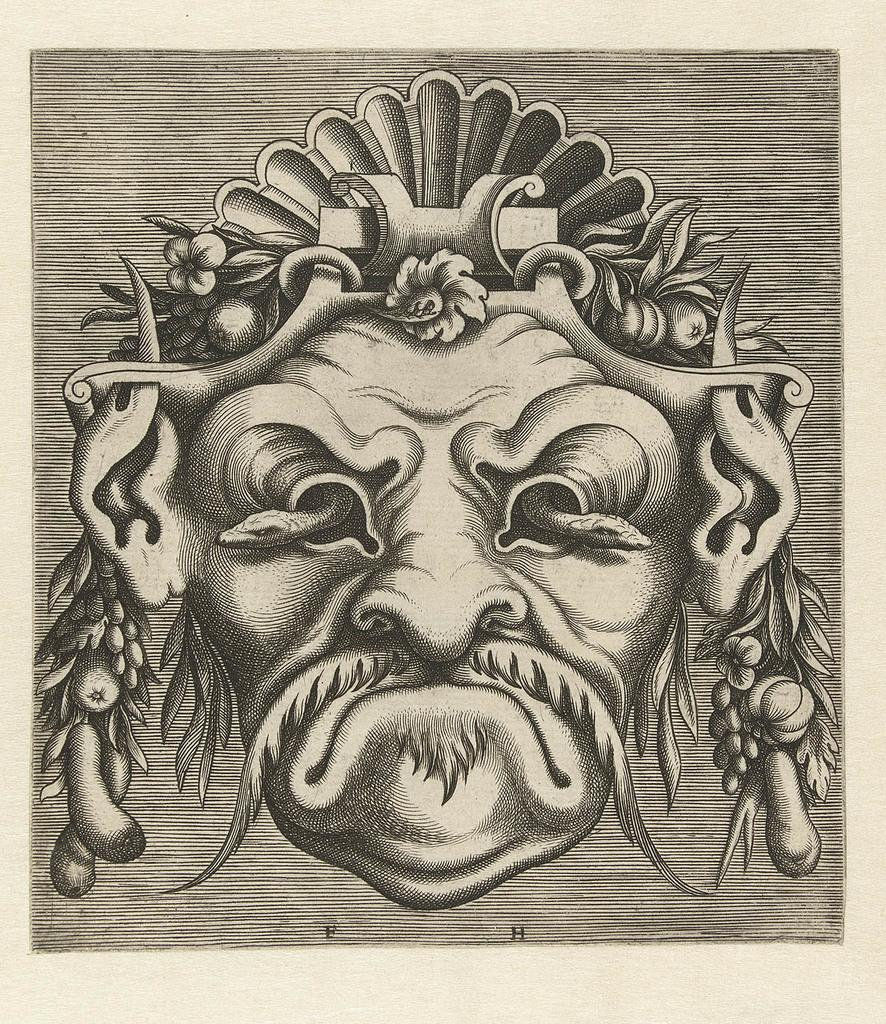What is depicted on the paper in the image? There is a sketch on a paper in the image. What type of liquid can be seen flowing from the volcano in the image? There is no volcano present in the image; it only features a sketch on a paper. What riddle is depicted in the sketch on the paper? The sketch on the paper does not depict a riddle; it is simply a sketch. 